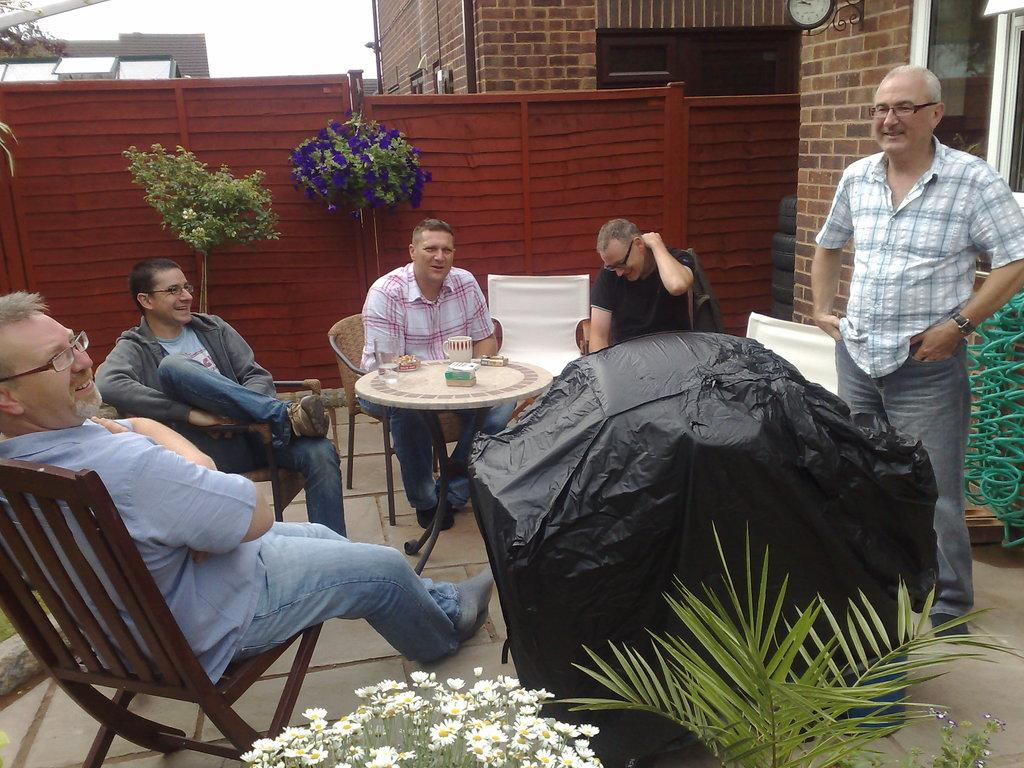How many people are sitting in the image? There are four persons sitting on chairs in the image. Is there anyone standing in the image? Yes, there is one person standing in the image. What is present on the table in the image? There is a cup on the table in the image. What can be seen in the background of the image? There is a building and a plant visible in the background. What type of horn is being played by the person standing in the image? There is no horn present in the image; the person standing is not playing any instrument. 